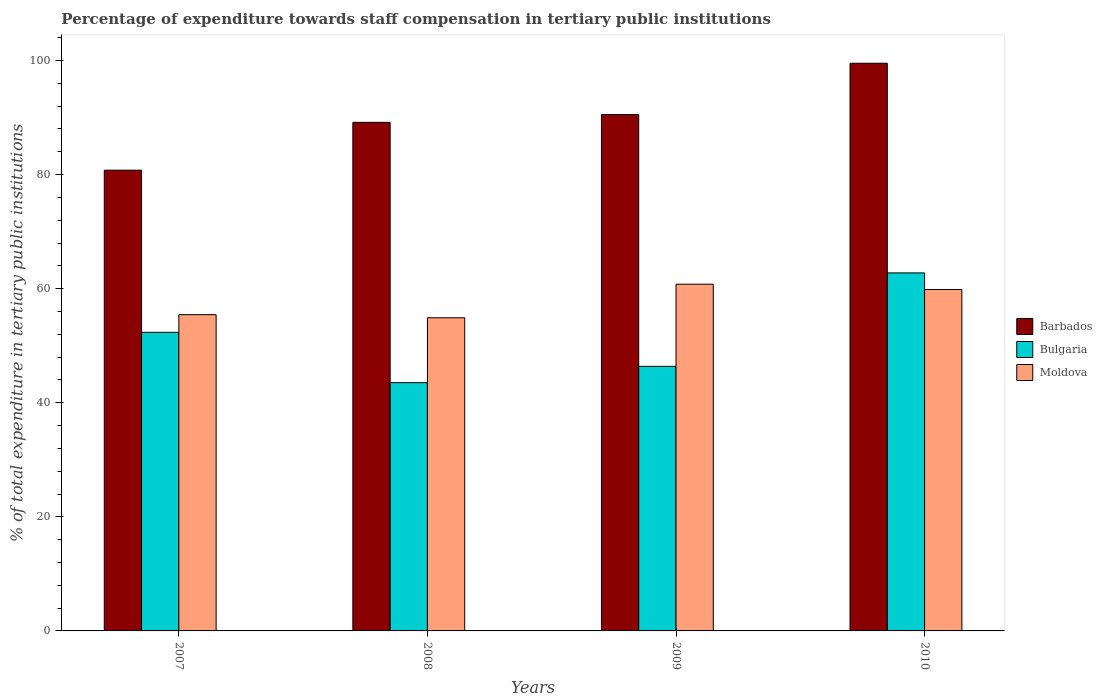How many groups of bars are there?
Give a very brief answer. 4. How many bars are there on the 4th tick from the left?
Your response must be concise. 3. What is the label of the 4th group of bars from the left?
Offer a very short reply. 2010. In how many cases, is the number of bars for a given year not equal to the number of legend labels?
Offer a terse response. 0. What is the percentage of expenditure towards staff compensation in Moldova in 2010?
Ensure brevity in your answer.  59.85. Across all years, what is the maximum percentage of expenditure towards staff compensation in Bulgaria?
Your answer should be compact. 62.76. Across all years, what is the minimum percentage of expenditure towards staff compensation in Barbados?
Provide a short and direct response. 80.77. In which year was the percentage of expenditure towards staff compensation in Bulgaria maximum?
Offer a terse response. 2010. In which year was the percentage of expenditure towards staff compensation in Moldova minimum?
Provide a succinct answer. 2008. What is the total percentage of expenditure towards staff compensation in Barbados in the graph?
Your answer should be compact. 359.94. What is the difference between the percentage of expenditure towards staff compensation in Barbados in 2007 and that in 2008?
Make the answer very short. -8.38. What is the difference between the percentage of expenditure towards staff compensation in Barbados in 2008 and the percentage of expenditure towards staff compensation in Bulgaria in 2009?
Your response must be concise. 42.77. What is the average percentage of expenditure towards staff compensation in Moldova per year?
Offer a very short reply. 57.74. In the year 2008, what is the difference between the percentage of expenditure towards staff compensation in Bulgaria and percentage of expenditure towards staff compensation in Moldova?
Your answer should be compact. -11.38. What is the ratio of the percentage of expenditure towards staff compensation in Moldova in 2008 to that in 2010?
Provide a short and direct response. 0.92. Is the percentage of expenditure towards staff compensation in Barbados in 2008 less than that in 2010?
Keep it short and to the point. Yes. Is the difference between the percentage of expenditure towards staff compensation in Bulgaria in 2007 and 2009 greater than the difference between the percentage of expenditure towards staff compensation in Moldova in 2007 and 2009?
Make the answer very short. Yes. What is the difference between the highest and the second highest percentage of expenditure towards staff compensation in Barbados?
Your response must be concise. 9. What is the difference between the highest and the lowest percentage of expenditure towards staff compensation in Barbados?
Make the answer very short. 18.74. In how many years, is the percentage of expenditure towards staff compensation in Bulgaria greater than the average percentage of expenditure towards staff compensation in Bulgaria taken over all years?
Keep it short and to the point. 2. What does the 3rd bar from the left in 2008 represents?
Keep it short and to the point. Moldova. What does the 1st bar from the right in 2010 represents?
Your answer should be very brief. Moldova. Is it the case that in every year, the sum of the percentage of expenditure towards staff compensation in Moldova and percentage of expenditure towards staff compensation in Bulgaria is greater than the percentage of expenditure towards staff compensation in Barbados?
Your answer should be very brief. Yes. How many years are there in the graph?
Offer a very short reply. 4. What is the difference between two consecutive major ticks on the Y-axis?
Provide a short and direct response. 20. Does the graph contain any zero values?
Keep it short and to the point. No. Where does the legend appear in the graph?
Give a very brief answer. Center right. How are the legend labels stacked?
Offer a terse response. Vertical. What is the title of the graph?
Make the answer very short. Percentage of expenditure towards staff compensation in tertiary public institutions. Does "Other small states" appear as one of the legend labels in the graph?
Offer a very short reply. No. What is the label or title of the X-axis?
Your answer should be compact. Years. What is the label or title of the Y-axis?
Provide a succinct answer. % of total expenditure in tertiary public institutions. What is the % of total expenditure in tertiary public institutions in Barbados in 2007?
Provide a short and direct response. 80.77. What is the % of total expenditure in tertiary public institutions of Bulgaria in 2007?
Your answer should be very brief. 52.34. What is the % of total expenditure in tertiary public institutions in Moldova in 2007?
Provide a succinct answer. 55.44. What is the % of total expenditure in tertiary public institutions of Barbados in 2008?
Your answer should be very brief. 89.15. What is the % of total expenditure in tertiary public institutions in Bulgaria in 2008?
Offer a terse response. 43.52. What is the % of total expenditure in tertiary public institutions in Moldova in 2008?
Offer a terse response. 54.9. What is the % of total expenditure in tertiary public institutions in Barbados in 2009?
Ensure brevity in your answer.  90.51. What is the % of total expenditure in tertiary public institutions of Bulgaria in 2009?
Provide a short and direct response. 46.38. What is the % of total expenditure in tertiary public institutions in Moldova in 2009?
Provide a short and direct response. 60.78. What is the % of total expenditure in tertiary public institutions in Barbados in 2010?
Ensure brevity in your answer.  99.51. What is the % of total expenditure in tertiary public institutions in Bulgaria in 2010?
Offer a terse response. 62.76. What is the % of total expenditure in tertiary public institutions of Moldova in 2010?
Give a very brief answer. 59.85. Across all years, what is the maximum % of total expenditure in tertiary public institutions in Barbados?
Ensure brevity in your answer.  99.51. Across all years, what is the maximum % of total expenditure in tertiary public institutions in Bulgaria?
Your response must be concise. 62.76. Across all years, what is the maximum % of total expenditure in tertiary public institutions of Moldova?
Provide a short and direct response. 60.78. Across all years, what is the minimum % of total expenditure in tertiary public institutions in Barbados?
Your response must be concise. 80.77. Across all years, what is the minimum % of total expenditure in tertiary public institutions in Bulgaria?
Provide a short and direct response. 43.52. Across all years, what is the minimum % of total expenditure in tertiary public institutions in Moldova?
Offer a very short reply. 54.9. What is the total % of total expenditure in tertiary public institutions in Barbados in the graph?
Your answer should be compact. 359.94. What is the total % of total expenditure in tertiary public institutions in Bulgaria in the graph?
Offer a very short reply. 205. What is the total % of total expenditure in tertiary public institutions of Moldova in the graph?
Offer a very short reply. 230.96. What is the difference between the % of total expenditure in tertiary public institutions in Barbados in 2007 and that in 2008?
Give a very brief answer. -8.38. What is the difference between the % of total expenditure in tertiary public institutions of Bulgaria in 2007 and that in 2008?
Make the answer very short. 8.82. What is the difference between the % of total expenditure in tertiary public institutions of Moldova in 2007 and that in 2008?
Your answer should be very brief. 0.54. What is the difference between the % of total expenditure in tertiary public institutions in Barbados in 2007 and that in 2009?
Offer a terse response. -9.74. What is the difference between the % of total expenditure in tertiary public institutions in Bulgaria in 2007 and that in 2009?
Your response must be concise. 5.96. What is the difference between the % of total expenditure in tertiary public institutions in Moldova in 2007 and that in 2009?
Your answer should be compact. -5.34. What is the difference between the % of total expenditure in tertiary public institutions of Barbados in 2007 and that in 2010?
Give a very brief answer. -18.74. What is the difference between the % of total expenditure in tertiary public institutions of Bulgaria in 2007 and that in 2010?
Offer a very short reply. -10.42. What is the difference between the % of total expenditure in tertiary public institutions of Moldova in 2007 and that in 2010?
Provide a succinct answer. -4.41. What is the difference between the % of total expenditure in tertiary public institutions of Barbados in 2008 and that in 2009?
Provide a short and direct response. -1.36. What is the difference between the % of total expenditure in tertiary public institutions of Bulgaria in 2008 and that in 2009?
Keep it short and to the point. -2.86. What is the difference between the % of total expenditure in tertiary public institutions in Moldova in 2008 and that in 2009?
Keep it short and to the point. -5.88. What is the difference between the % of total expenditure in tertiary public institutions in Barbados in 2008 and that in 2010?
Ensure brevity in your answer.  -10.36. What is the difference between the % of total expenditure in tertiary public institutions of Bulgaria in 2008 and that in 2010?
Offer a terse response. -19.24. What is the difference between the % of total expenditure in tertiary public institutions of Moldova in 2008 and that in 2010?
Make the answer very short. -4.95. What is the difference between the % of total expenditure in tertiary public institutions in Barbados in 2009 and that in 2010?
Provide a short and direct response. -9. What is the difference between the % of total expenditure in tertiary public institutions of Bulgaria in 2009 and that in 2010?
Keep it short and to the point. -16.38. What is the difference between the % of total expenditure in tertiary public institutions of Moldova in 2009 and that in 2010?
Your answer should be very brief. 0.93. What is the difference between the % of total expenditure in tertiary public institutions in Barbados in 2007 and the % of total expenditure in tertiary public institutions in Bulgaria in 2008?
Your answer should be very brief. 37.25. What is the difference between the % of total expenditure in tertiary public institutions in Barbados in 2007 and the % of total expenditure in tertiary public institutions in Moldova in 2008?
Ensure brevity in your answer.  25.87. What is the difference between the % of total expenditure in tertiary public institutions of Bulgaria in 2007 and the % of total expenditure in tertiary public institutions of Moldova in 2008?
Keep it short and to the point. -2.56. What is the difference between the % of total expenditure in tertiary public institutions in Barbados in 2007 and the % of total expenditure in tertiary public institutions in Bulgaria in 2009?
Your answer should be compact. 34.39. What is the difference between the % of total expenditure in tertiary public institutions of Barbados in 2007 and the % of total expenditure in tertiary public institutions of Moldova in 2009?
Provide a short and direct response. 19.99. What is the difference between the % of total expenditure in tertiary public institutions in Bulgaria in 2007 and the % of total expenditure in tertiary public institutions in Moldova in 2009?
Your answer should be compact. -8.43. What is the difference between the % of total expenditure in tertiary public institutions of Barbados in 2007 and the % of total expenditure in tertiary public institutions of Bulgaria in 2010?
Give a very brief answer. 18.01. What is the difference between the % of total expenditure in tertiary public institutions of Barbados in 2007 and the % of total expenditure in tertiary public institutions of Moldova in 2010?
Keep it short and to the point. 20.92. What is the difference between the % of total expenditure in tertiary public institutions of Bulgaria in 2007 and the % of total expenditure in tertiary public institutions of Moldova in 2010?
Your answer should be very brief. -7.5. What is the difference between the % of total expenditure in tertiary public institutions in Barbados in 2008 and the % of total expenditure in tertiary public institutions in Bulgaria in 2009?
Provide a short and direct response. 42.77. What is the difference between the % of total expenditure in tertiary public institutions in Barbados in 2008 and the % of total expenditure in tertiary public institutions in Moldova in 2009?
Your answer should be very brief. 28.37. What is the difference between the % of total expenditure in tertiary public institutions in Bulgaria in 2008 and the % of total expenditure in tertiary public institutions in Moldova in 2009?
Your answer should be very brief. -17.26. What is the difference between the % of total expenditure in tertiary public institutions of Barbados in 2008 and the % of total expenditure in tertiary public institutions of Bulgaria in 2010?
Make the answer very short. 26.39. What is the difference between the % of total expenditure in tertiary public institutions in Barbados in 2008 and the % of total expenditure in tertiary public institutions in Moldova in 2010?
Offer a very short reply. 29.31. What is the difference between the % of total expenditure in tertiary public institutions of Bulgaria in 2008 and the % of total expenditure in tertiary public institutions of Moldova in 2010?
Your answer should be compact. -16.33. What is the difference between the % of total expenditure in tertiary public institutions in Barbados in 2009 and the % of total expenditure in tertiary public institutions in Bulgaria in 2010?
Your answer should be compact. 27.75. What is the difference between the % of total expenditure in tertiary public institutions of Barbados in 2009 and the % of total expenditure in tertiary public institutions of Moldova in 2010?
Provide a short and direct response. 30.66. What is the difference between the % of total expenditure in tertiary public institutions of Bulgaria in 2009 and the % of total expenditure in tertiary public institutions of Moldova in 2010?
Give a very brief answer. -13.46. What is the average % of total expenditure in tertiary public institutions of Barbados per year?
Give a very brief answer. 89.98. What is the average % of total expenditure in tertiary public institutions in Bulgaria per year?
Give a very brief answer. 51.25. What is the average % of total expenditure in tertiary public institutions in Moldova per year?
Provide a short and direct response. 57.74. In the year 2007, what is the difference between the % of total expenditure in tertiary public institutions in Barbados and % of total expenditure in tertiary public institutions in Bulgaria?
Give a very brief answer. 28.42. In the year 2007, what is the difference between the % of total expenditure in tertiary public institutions in Barbados and % of total expenditure in tertiary public institutions in Moldova?
Give a very brief answer. 25.33. In the year 2007, what is the difference between the % of total expenditure in tertiary public institutions in Bulgaria and % of total expenditure in tertiary public institutions in Moldova?
Provide a short and direct response. -3.09. In the year 2008, what is the difference between the % of total expenditure in tertiary public institutions in Barbados and % of total expenditure in tertiary public institutions in Bulgaria?
Offer a terse response. 45.63. In the year 2008, what is the difference between the % of total expenditure in tertiary public institutions in Barbados and % of total expenditure in tertiary public institutions in Moldova?
Make the answer very short. 34.25. In the year 2008, what is the difference between the % of total expenditure in tertiary public institutions of Bulgaria and % of total expenditure in tertiary public institutions of Moldova?
Offer a terse response. -11.38. In the year 2009, what is the difference between the % of total expenditure in tertiary public institutions in Barbados and % of total expenditure in tertiary public institutions in Bulgaria?
Provide a succinct answer. 44.13. In the year 2009, what is the difference between the % of total expenditure in tertiary public institutions in Barbados and % of total expenditure in tertiary public institutions in Moldova?
Your response must be concise. 29.73. In the year 2009, what is the difference between the % of total expenditure in tertiary public institutions of Bulgaria and % of total expenditure in tertiary public institutions of Moldova?
Offer a terse response. -14.4. In the year 2010, what is the difference between the % of total expenditure in tertiary public institutions in Barbados and % of total expenditure in tertiary public institutions in Bulgaria?
Provide a succinct answer. 36.75. In the year 2010, what is the difference between the % of total expenditure in tertiary public institutions of Barbados and % of total expenditure in tertiary public institutions of Moldova?
Offer a very short reply. 39.66. In the year 2010, what is the difference between the % of total expenditure in tertiary public institutions of Bulgaria and % of total expenditure in tertiary public institutions of Moldova?
Your answer should be very brief. 2.91. What is the ratio of the % of total expenditure in tertiary public institutions in Barbados in 2007 to that in 2008?
Give a very brief answer. 0.91. What is the ratio of the % of total expenditure in tertiary public institutions of Bulgaria in 2007 to that in 2008?
Keep it short and to the point. 1.2. What is the ratio of the % of total expenditure in tertiary public institutions of Moldova in 2007 to that in 2008?
Offer a terse response. 1.01. What is the ratio of the % of total expenditure in tertiary public institutions of Barbados in 2007 to that in 2009?
Your response must be concise. 0.89. What is the ratio of the % of total expenditure in tertiary public institutions of Bulgaria in 2007 to that in 2009?
Ensure brevity in your answer.  1.13. What is the ratio of the % of total expenditure in tertiary public institutions in Moldova in 2007 to that in 2009?
Ensure brevity in your answer.  0.91. What is the ratio of the % of total expenditure in tertiary public institutions in Barbados in 2007 to that in 2010?
Ensure brevity in your answer.  0.81. What is the ratio of the % of total expenditure in tertiary public institutions in Bulgaria in 2007 to that in 2010?
Ensure brevity in your answer.  0.83. What is the ratio of the % of total expenditure in tertiary public institutions of Moldova in 2007 to that in 2010?
Provide a succinct answer. 0.93. What is the ratio of the % of total expenditure in tertiary public institutions of Bulgaria in 2008 to that in 2009?
Offer a terse response. 0.94. What is the ratio of the % of total expenditure in tertiary public institutions in Moldova in 2008 to that in 2009?
Provide a short and direct response. 0.9. What is the ratio of the % of total expenditure in tertiary public institutions of Barbados in 2008 to that in 2010?
Provide a short and direct response. 0.9. What is the ratio of the % of total expenditure in tertiary public institutions in Bulgaria in 2008 to that in 2010?
Ensure brevity in your answer.  0.69. What is the ratio of the % of total expenditure in tertiary public institutions in Moldova in 2008 to that in 2010?
Ensure brevity in your answer.  0.92. What is the ratio of the % of total expenditure in tertiary public institutions in Barbados in 2009 to that in 2010?
Ensure brevity in your answer.  0.91. What is the ratio of the % of total expenditure in tertiary public institutions in Bulgaria in 2009 to that in 2010?
Ensure brevity in your answer.  0.74. What is the ratio of the % of total expenditure in tertiary public institutions of Moldova in 2009 to that in 2010?
Make the answer very short. 1.02. What is the difference between the highest and the second highest % of total expenditure in tertiary public institutions of Barbados?
Ensure brevity in your answer.  9. What is the difference between the highest and the second highest % of total expenditure in tertiary public institutions in Bulgaria?
Make the answer very short. 10.42. What is the difference between the highest and the second highest % of total expenditure in tertiary public institutions in Moldova?
Offer a very short reply. 0.93. What is the difference between the highest and the lowest % of total expenditure in tertiary public institutions of Barbados?
Give a very brief answer. 18.74. What is the difference between the highest and the lowest % of total expenditure in tertiary public institutions in Bulgaria?
Provide a succinct answer. 19.24. What is the difference between the highest and the lowest % of total expenditure in tertiary public institutions of Moldova?
Provide a succinct answer. 5.88. 